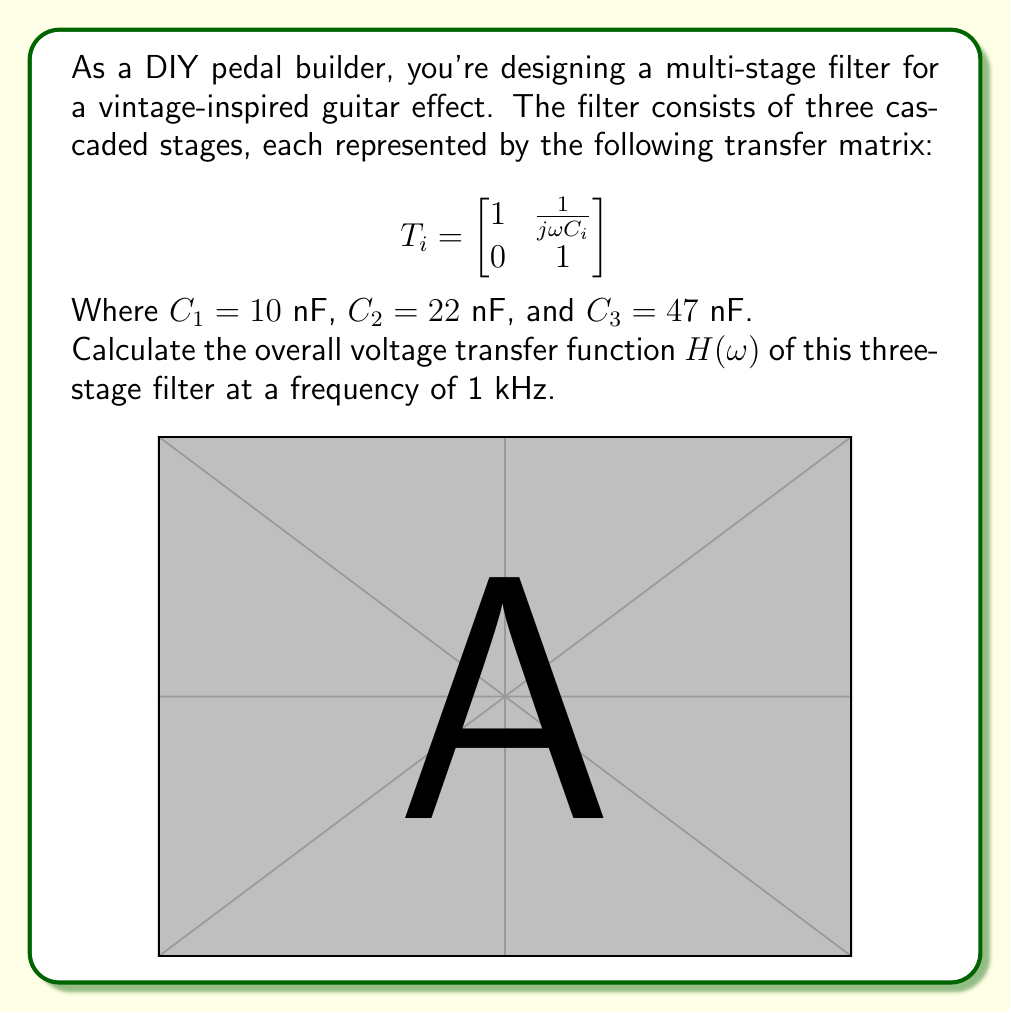Could you help me with this problem? Let's approach this step-by-step:

1) The overall transfer matrix is the product of individual stage matrices:

   $$T_{total} = T_3 \cdot T_2 \cdot T_1$$

2) First, let's calculate $\omega$ at 1 kHz:
   
   $$\omega = 2\pi f = 2\pi \cdot 1000 = 6283.19 \text{ rad/s}$$

3) Now, let's calculate each transfer matrix:

   $$T_1 = \begin{bmatrix}
   1 & \frac{1}{j\omega C_1} \\
   0 & 1
   \end{bmatrix} = \begin{bmatrix}
   1 & \frac{1}{j \cdot 6283.19 \cdot 10 \times 10^{-9}} \\
   0 & 1
   \end{bmatrix} = \begin{bmatrix}
   1 & -j15915.5 \\
   0 & 1
   \end{bmatrix}$$

   $$T_2 = \begin{bmatrix}
   1 & -j7234.32 \\
   0 & 1
   \end{bmatrix}$$

   $$T_3 = \begin{bmatrix}
   1 & -j3385.74 \\
   0 & 1
   \end{bmatrix}$$

4) Multiply these matrices:

   $$T_{total} = \begin{bmatrix}
   1 & -j3385.74 \\
   0 & 1
   \end{bmatrix} \cdot \begin{bmatrix}
   1 & -j7234.32 \\
   0 & 1
   \end{bmatrix} \cdot \begin{bmatrix}
   1 & -j15915.5 \\
   0 & 1
   \end{bmatrix}$$

   $$= \begin{bmatrix}
   1 & -j(3385.74 + 7234.32 + 15915.5) \\
   0 & 1
   \end{bmatrix} = \begin{bmatrix}
   1 & -j26535.56 \\
   0 & 1
   \end{bmatrix}$$

5) The voltage transfer function $H(\omega)$ is the reciprocal of the (1,2) element of $T_{total}$:

   $$H(\omega) = \frac{1}{-j26535.56} = \frac{j}{26535.56} = 3.768 \times 10^{-5} \angle 90°$$

6) Convert to magnitude and phase:

   Magnitude: $|H(\omega)| = 3.768 \times 10^{-5}$
   Phase: $\angle H(\omega) = 90°$
Answer: $H(\omega) = 3.768 \times 10^{-5} \angle 90°$ 